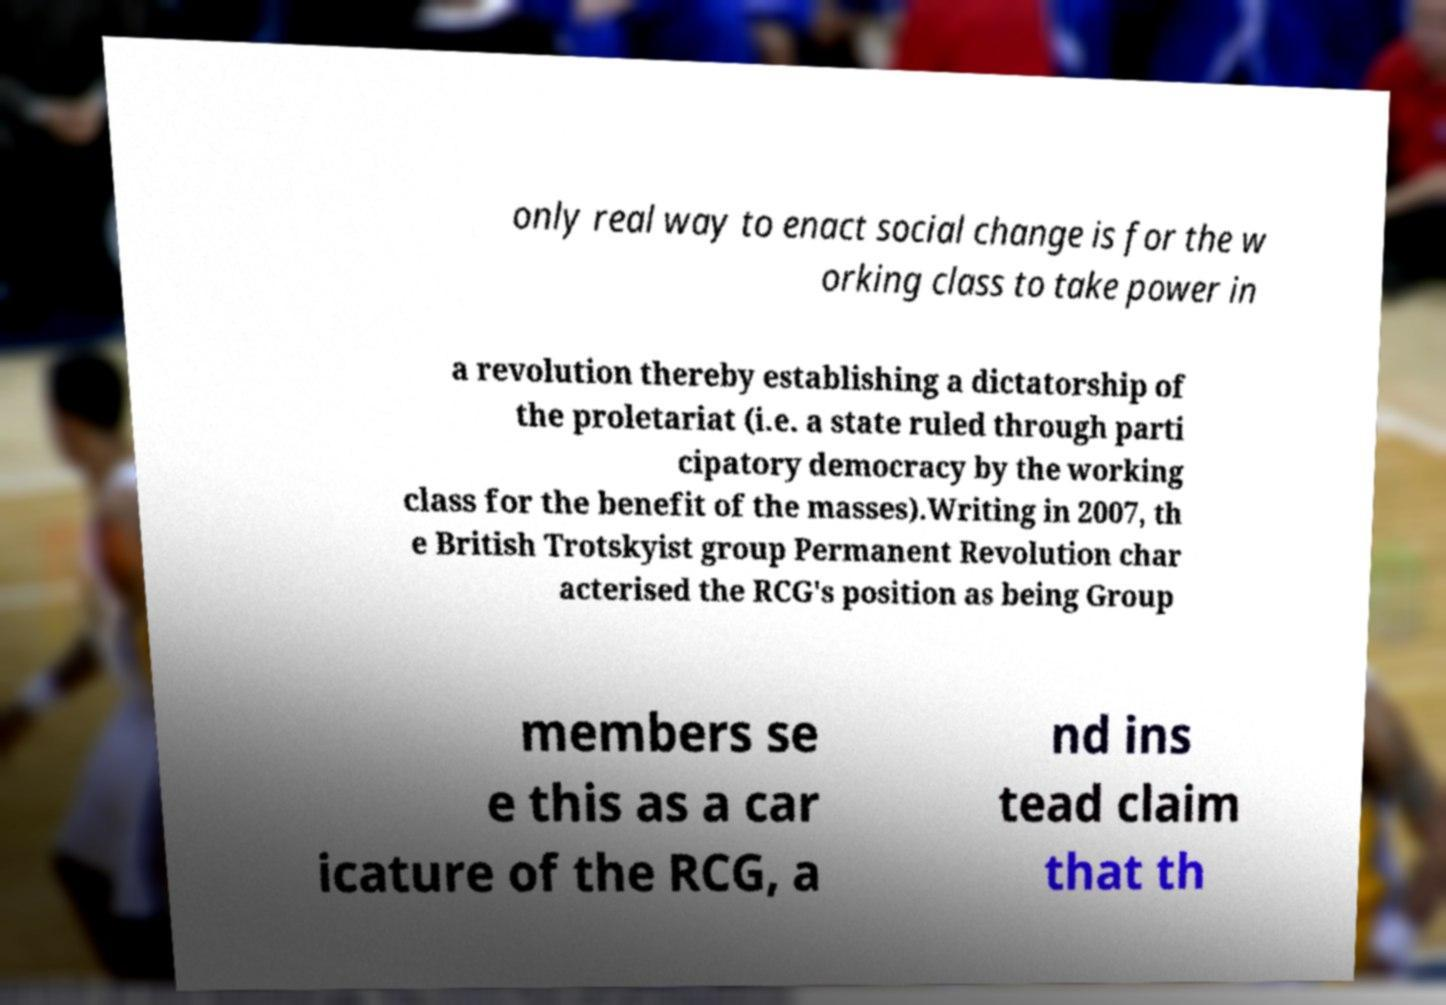I need the written content from this picture converted into text. Can you do that? only real way to enact social change is for the w orking class to take power in a revolution thereby establishing a dictatorship of the proletariat (i.e. a state ruled through parti cipatory democracy by the working class for the benefit of the masses).Writing in 2007, th e British Trotskyist group Permanent Revolution char acterised the RCG's position as being Group members se e this as a car icature of the RCG, a nd ins tead claim that th 